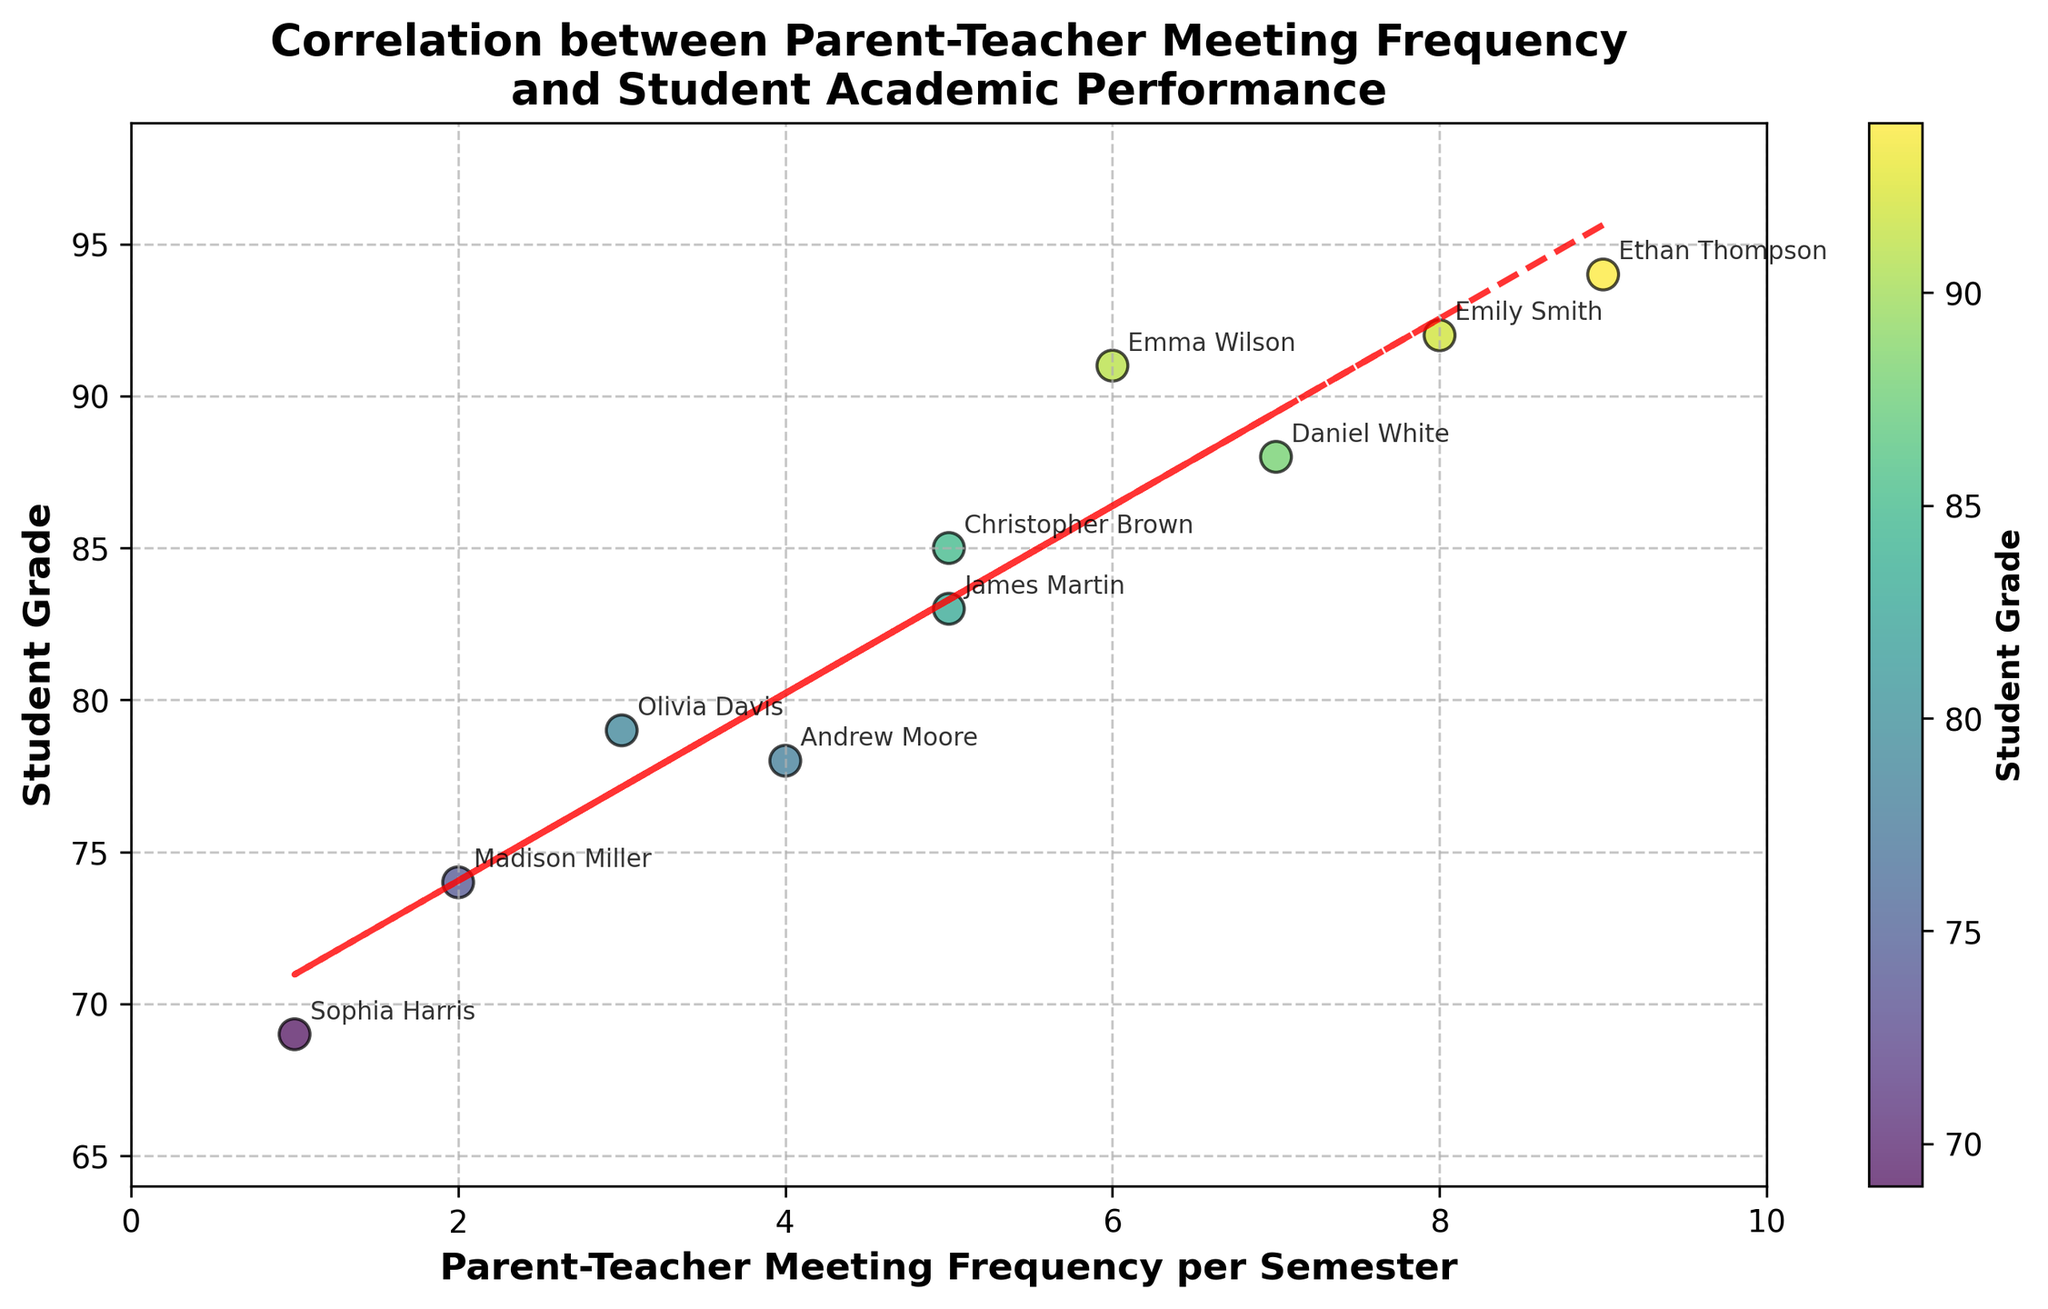What is the title of the figure? The title is located at the top of the figure. It is clearly stated in bold text.
Answer: Correlation between Parent-Teacher Meeting Frequency and Student Academic Performance How many total data points are shown in the scatter plot? Each point represents one student, and there are dots marked with their respective student names. Counting each point will give the total number.
Answer: 10 What are the x-axis and y-axis labels? The x-axis label can be found below the horizontal axis, while the y-axis label can be found to the left of the vertical axis. Both are stated explicitly in bold text.
Answer: Parent-Teacher Meeting Frequency per Semester (x-axis), Student Grade (y-axis) Which student has the highest grade, and what is their parent-teacher meeting frequency? Look for the highest point on the y-axis and check its corresponding x-axis value. Read the text annotations to find the student's name.
Answer: Ethan Thompson, 9 Which student has the lowest grade, and what is their parent-teacher meeting frequency? Look for the lowest point on the y-axis and check its corresponding x-axis value. Read the text annotations to find the student's name.
Answer: Sophia Harris, 1 What trend can be observed from the trend line in the scatter plot? The trend line shows the general direction of the data points. The slope of the line indicates the relationship between the two variables.
Answer: Positive correlation What is the approximate equation of the trend line? The trend line is a linear regression line fitted to the data points. The equation can be derived from the coefficient and intercept values labeled on the line.
Answer: \( y = 2.47x + 70.21 \) How does the trend line help in interpreting the data? The trend line indicates the general direction of the data points, showing how one variable (student grades) tends to change as the other variable (meeting frequency) changes. A positive slope suggests that higher meeting frequencies are associated with higher grades.
Answer: Indicates positive correlation For a student with 4 meetings per semester, what is their expected grade according to the trend line? Substitute x = 4 into the trend line equation: \( y = 2.47(4) + 70.21 \). Calculate the result to find the expected grade.
Answer: 79.09 Compare the grades of students who had 5 meetings per semester. Who has the higher grade, and by how much? Find the grades of students with 5 meetings (Christopher Brown and James Martin). Subtract the lower grade from the higher grade to get the difference.
Answer: Christopher Brown has the higher grade by 2 points 